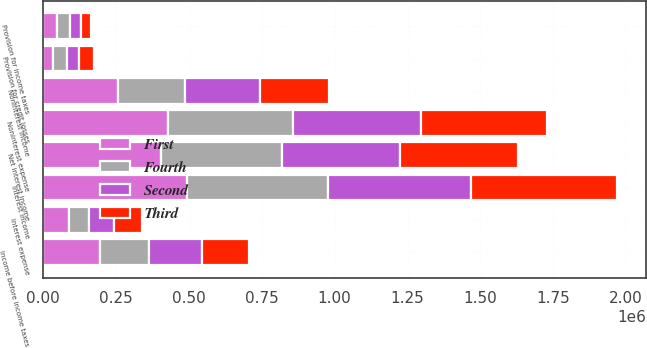<chart> <loc_0><loc_0><loc_500><loc_500><stacked_bar_chart><ecel><fcel>Interest income<fcel>Interest expense<fcel>Net interest income<fcel>Provision for credit losses<fcel>Noninterest income<fcel>Noninterest expense<fcel>Income before income taxes<fcel>Provision for income taxes<nl><fcel>Fourth<fcel>485216<fcel>70191<fcel>415025<fcel>45291<fcel>229352<fcel>430274<fcel>168812<fcel>41954<nl><fcel>Second<fcel>490996<fcel>84518<fcel>406478<fcel>43586<fcel>258559<fcel>439118<fcel>182333<fcel>38942<nl><fcel>First<fcel>492137<fcel>88800<fcel>403337<fcel>35797<fcel>255767<fcel>428409<fcel>194898<fcel>48980<nl><fcel>Third<fcel>501877<fcel>97547<fcel>404330<fcel>49385<fcel>236945<fcel>430699<fcel>161191<fcel>34745<nl></chart> 